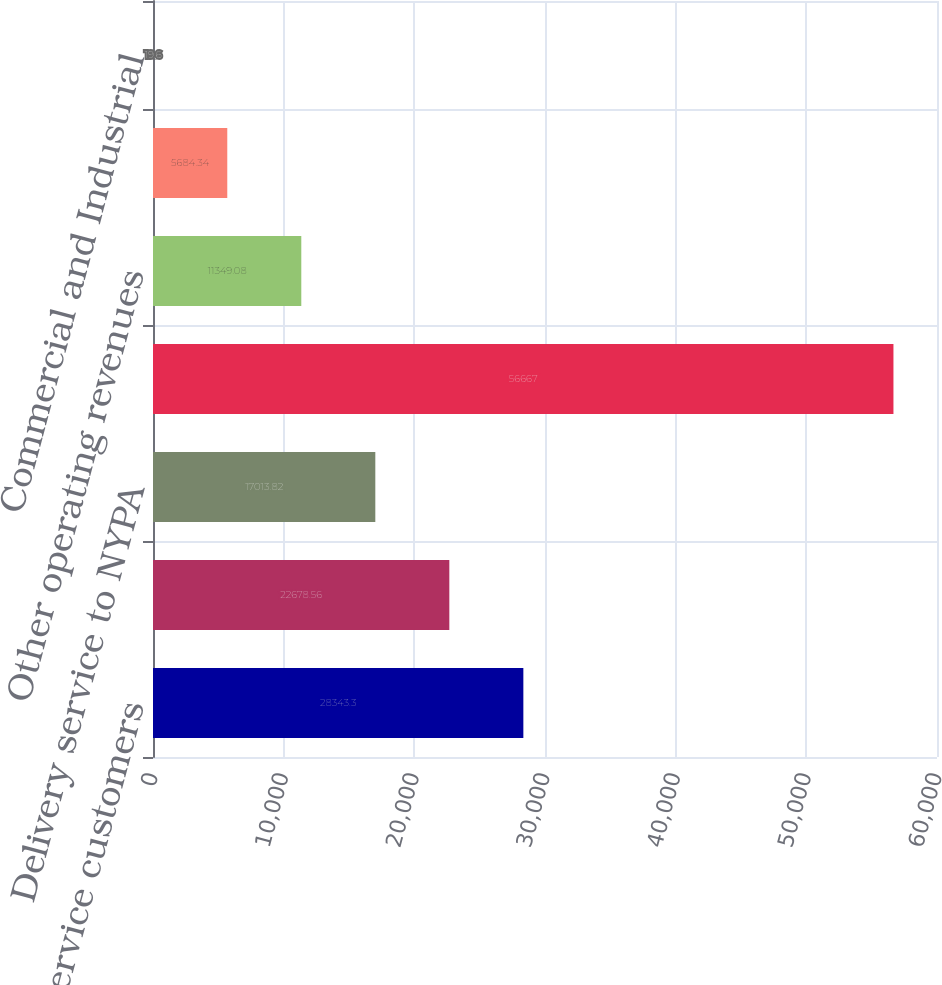Convert chart. <chart><loc_0><loc_0><loc_500><loc_500><bar_chart><fcel>CECONY full service customers<fcel>Delivery service for retail<fcel>Delivery service to NYPA<fcel>Total Deliveries in Franchise<fcel>Other operating revenues<fcel>Residential<fcel>Commercial and Industrial<nl><fcel>28343.3<fcel>22678.6<fcel>17013.8<fcel>56667<fcel>11349.1<fcel>5684.34<fcel>19.6<nl></chart> 